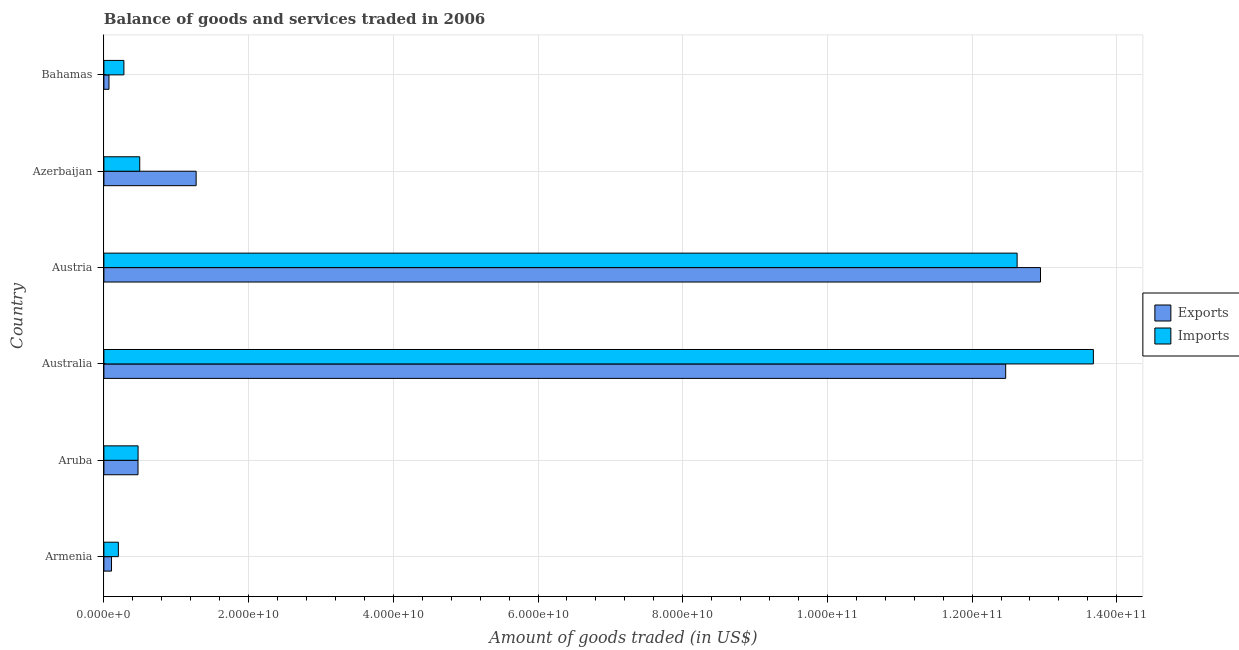How many different coloured bars are there?
Offer a very short reply. 2. How many groups of bars are there?
Your answer should be compact. 6. Are the number of bars per tick equal to the number of legend labels?
Your answer should be compact. Yes. How many bars are there on the 3rd tick from the bottom?
Your answer should be very brief. 2. What is the label of the 6th group of bars from the top?
Your answer should be compact. Armenia. What is the amount of goods imported in Australia?
Provide a succinct answer. 1.37e+11. Across all countries, what is the maximum amount of goods imported?
Offer a very short reply. 1.37e+11. Across all countries, what is the minimum amount of goods imported?
Keep it short and to the point. 2.00e+09. In which country was the amount of goods imported maximum?
Ensure brevity in your answer.  Australia. In which country was the amount of goods imported minimum?
Give a very brief answer. Armenia. What is the total amount of goods exported in the graph?
Give a very brief answer. 2.73e+11. What is the difference between the amount of goods exported in Australia and that in Bahamas?
Offer a terse response. 1.24e+11. What is the difference between the amount of goods exported in Australia and the amount of goods imported in Armenia?
Keep it short and to the point. 1.23e+11. What is the average amount of goods exported per country?
Give a very brief answer. 4.56e+1. What is the difference between the amount of goods exported and amount of goods imported in Australia?
Offer a very short reply. -1.21e+1. What is the ratio of the amount of goods exported in Australia to that in Austria?
Make the answer very short. 0.96. Is the amount of goods exported in Aruba less than that in Austria?
Ensure brevity in your answer.  Yes. Is the difference between the amount of goods exported in Australia and Austria greater than the difference between the amount of goods imported in Australia and Austria?
Provide a short and direct response. No. What is the difference between the highest and the second highest amount of goods exported?
Keep it short and to the point. 4.81e+09. What is the difference between the highest and the lowest amount of goods imported?
Make the answer very short. 1.35e+11. In how many countries, is the amount of goods imported greater than the average amount of goods imported taken over all countries?
Offer a terse response. 2. Is the sum of the amount of goods exported in Aruba and Bahamas greater than the maximum amount of goods imported across all countries?
Provide a succinct answer. No. What does the 2nd bar from the top in Australia represents?
Offer a terse response. Exports. What does the 2nd bar from the bottom in Austria represents?
Give a very brief answer. Imports. Are all the bars in the graph horizontal?
Ensure brevity in your answer.  Yes. How many countries are there in the graph?
Your answer should be very brief. 6. Are the values on the major ticks of X-axis written in scientific E-notation?
Your answer should be very brief. Yes. Does the graph contain any zero values?
Provide a succinct answer. No. How are the legend labels stacked?
Make the answer very short. Vertical. What is the title of the graph?
Make the answer very short. Balance of goods and services traded in 2006. What is the label or title of the X-axis?
Ensure brevity in your answer.  Amount of goods traded (in US$). What is the Amount of goods traded (in US$) in Exports in Armenia?
Offer a very short reply. 1.05e+09. What is the Amount of goods traded (in US$) of Imports in Armenia?
Your response must be concise. 2.00e+09. What is the Amount of goods traded (in US$) in Exports in Aruba?
Provide a short and direct response. 4.72e+09. What is the Amount of goods traded (in US$) in Imports in Aruba?
Offer a very short reply. 4.72e+09. What is the Amount of goods traded (in US$) of Exports in Australia?
Keep it short and to the point. 1.25e+11. What is the Amount of goods traded (in US$) in Imports in Australia?
Your answer should be compact. 1.37e+11. What is the Amount of goods traded (in US$) in Exports in Austria?
Ensure brevity in your answer.  1.29e+11. What is the Amount of goods traded (in US$) in Imports in Austria?
Provide a succinct answer. 1.26e+11. What is the Amount of goods traded (in US$) in Exports in Azerbaijan?
Keep it short and to the point. 1.27e+1. What is the Amount of goods traded (in US$) of Imports in Azerbaijan?
Offer a terse response. 4.95e+09. What is the Amount of goods traded (in US$) in Exports in Bahamas?
Keep it short and to the point. 7.04e+08. What is the Amount of goods traded (in US$) of Imports in Bahamas?
Provide a short and direct response. 2.77e+09. Across all countries, what is the maximum Amount of goods traded (in US$) in Exports?
Provide a succinct answer. 1.29e+11. Across all countries, what is the maximum Amount of goods traded (in US$) of Imports?
Provide a succinct answer. 1.37e+11. Across all countries, what is the minimum Amount of goods traded (in US$) of Exports?
Your answer should be compact. 7.04e+08. Across all countries, what is the minimum Amount of goods traded (in US$) in Imports?
Give a very brief answer. 2.00e+09. What is the total Amount of goods traded (in US$) of Exports in the graph?
Your response must be concise. 2.73e+11. What is the total Amount of goods traded (in US$) of Imports in the graph?
Ensure brevity in your answer.  2.77e+11. What is the difference between the Amount of goods traded (in US$) of Exports in Armenia and that in Aruba?
Make the answer very short. -3.66e+09. What is the difference between the Amount of goods traded (in US$) of Imports in Armenia and that in Aruba?
Offer a terse response. -2.72e+09. What is the difference between the Amount of goods traded (in US$) in Exports in Armenia and that in Australia?
Keep it short and to the point. -1.24e+11. What is the difference between the Amount of goods traded (in US$) in Imports in Armenia and that in Australia?
Make the answer very short. -1.35e+11. What is the difference between the Amount of goods traded (in US$) in Exports in Armenia and that in Austria?
Provide a succinct answer. -1.28e+11. What is the difference between the Amount of goods traded (in US$) in Imports in Armenia and that in Austria?
Your response must be concise. -1.24e+11. What is the difference between the Amount of goods traded (in US$) of Exports in Armenia and that in Azerbaijan?
Your answer should be very brief. -1.17e+1. What is the difference between the Amount of goods traded (in US$) in Imports in Armenia and that in Azerbaijan?
Offer a very short reply. -2.95e+09. What is the difference between the Amount of goods traded (in US$) in Exports in Armenia and that in Bahamas?
Ensure brevity in your answer.  3.49e+08. What is the difference between the Amount of goods traded (in US$) in Imports in Armenia and that in Bahamas?
Offer a very short reply. -7.67e+08. What is the difference between the Amount of goods traded (in US$) in Exports in Aruba and that in Australia?
Keep it short and to the point. -1.20e+11. What is the difference between the Amount of goods traded (in US$) of Imports in Aruba and that in Australia?
Your response must be concise. -1.32e+11. What is the difference between the Amount of goods traded (in US$) in Exports in Aruba and that in Austria?
Offer a terse response. -1.25e+11. What is the difference between the Amount of goods traded (in US$) of Imports in Aruba and that in Austria?
Make the answer very short. -1.21e+11. What is the difference between the Amount of goods traded (in US$) in Exports in Aruba and that in Azerbaijan?
Keep it short and to the point. -8.03e+09. What is the difference between the Amount of goods traded (in US$) of Imports in Aruba and that in Azerbaijan?
Your answer should be very brief. -2.30e+08. What is the difference between the Amount of goods traded (in US$) of Exports in Aruba and that in Bahamas?
Provide a succinct answer. 4.01e+09. What is the difference between the Amount of goods traded (in US$) of Imports in Aruba and that in Bahamas?
Make the answer very short. 1.96e+09. What is the difference between the Amount of goods traded (in US$) in Exports in Australia and that in Austria?
Offer a terse response. -4.81e+09. What is the difference between the Amount of goods traded (in US$) in Imports in Australia and that in Austria?
Provide a succinct answer. 1.05e+1. What is the difference between the Amount of goods traded (in US$) in Exports in Australia and that in Azerbaijan?
Make the answer very short. 1.12e+11. What is the difference between the Amount of goods traded (in US$) in Imports in Australia and that in Azerbaijan?
Give a very brief answer. 1.32e+11. What is the difference between the Amount of goods traded (in US$) of Exports in Australia and that in Bahamas?
Make the answer very short. 1.24e+11. What is the difference between the Amount of goods traded (in US$) of Imports in Australia and that in Bahamas?
Give a very brief answer. 1.34e+11. What is the difference between the Amount of goods traded (in US$) of Exports in Austria and that in Azerbaijan?
Your answer should be very brief. 1.17e+11. What is the difference between the Amount of goods traded (in US$) of Imports in Austria and that in Azerbaijan?
Keep it short and to the point. 1.21e+11. What is the difference between the Amount of goods traded (in US$) of Exports in Austria and that in Bahamas?
Offer a very short reply. 1.29e+11. What is the difference between the Amount of goods traded (in US$) in Imports in Austria and that in Bahamas?
Your answer should be compact. 1.23e+11. What is the difference between the Amount of goods traded (in US$) in Exports in Azerbaijan and that in Bahamas?
Make the answer very short. 1.20e+1. What is the difference between the Amount of goods traded (in US$) of Imports in Azerbaijan and that in Bahamas?
Your answer should be very brief. 2.19e+09. What is the difference between the Amount of goods traded (in US$) of Exports in Armenia and the Amount of goods traded (in US$) of Imports in Aruba?
Your response must be concise. -3.67e+09. What is the difference between the Amount of goods traded (in US$) of Exports in Armenia and the Amount of goods traded (in US$) of Imports in Australia?
Offer a very short reply. -1.36e+11. What is the difference between the Amount of goods traded (in US$) of Exports in Armenia and the Amount of goods traded (in US$) of Imports in Austria?
Your answer should be very brief. -1.25e+11. What is the difference between the Amount of goods traded (in US$) in Exports in Armenia and the Amount of goods traded (in US$) in Imports in Azerbaijan?
Provide a succinct answer. -3.90e+09. What is the difference between the Amount of goods traded (in US$) in Exports in Armenia and the Amount of goods traded (in US$) in Imports in Bahamas?
Make the answer very short. -1.71e+09. What is the difference between the Amount of goods traded (in US$) in Exports in Aruba and the Amount of goods traded (in US$) in Imports in Australia?
Your answer should be compact. -1.32e+11. What is the difference between the Amount of goods traded (in US$) in Exports in Aruba and the Amount of goods traded (in US$) in Imports in Austria?
Offer a terse response. -1.22e+11. What is the difference between the Amount of goods traded (in US$) in Exports in Aruba and the Amount of goods traded (in US$) in Imports in Azerbaijan?
Provide a short and direct response. -2.37e+08. What is the difference between the Amount of goods traded (in US$) of Exports in Aruba and the Amount of goods traded (in US$) of Imports in Bahamas?
Offer a terse response. 1.95e+09. What is the difference between the Amount of goods traded (in US$) of Exports in Australia and the Amount of goods traded (in US$) of Imports in Austria?
Your answer should be compact. -1.58e+09. What is the difference between the Amount of goods traded (in US$) of Exports in Australia and the Amount of goods traded (in US$) of Imports in Azerbaijan?
Ensure brevity in your answer.  1.20e+11. What is the difference between the Amount of goods traded (in US$) in Exports in Australia and the Amount of goods traded (in US$) in Imports in Bahamas?
Provide a succinct answer. 1.22e+11. What is the difference between the Amount of goods traded (in US$) in Exports in Austria and the Amount of goods traded (in US$) in Imports in Azerbaijan?
Your answer should be compact. 1.24e+11. What is the difference between the Amount of goods traded (in US$) of Exports in Austria and the Amount of goods traded (in US$) of Imports in Bahamas?
Your answer should be very brief. 1.27e+11. What is the difference between the Amount of goods traded (in US$) of Exports in Azerbaijan and the Amount of goods traded (in US$) of Imports in Bahamas?
Make the answer very short. 9.98e+09. What is the average Amount of goods traded (in US$) of Exports per country?
Provide a succinct answer. 4.56e+1. What is the average Amount of goods traded (in US$) of Imports per country?
Provide a succinct answer. 4.62e+1. What is the difference between the Amount of goods traded (in US$) of Exports and Amount of goods traded (in US$) of Imports in Armenia?
Provide a short and direct response. -9.47e+08. What is the difference between the Amount of goods traded (in US$) of Exports and Amount of goods traded (in US$) of Imports in Aruba?
Your response must be concise. -7.32e+06. What is the difference between the Amount of goods traded (in US$) of Exports and Amount of goods traded (in US$) of Imports in Australia?
Provide a succinct answer. -1.21e+1. What is the difference between the Amount of goods traded (in US$) of Exports and Amount of goods traded (in US$) of Imports in Austria?
Your answer should be compact. 3.23e+09. What is the difference between the Amount of goods traded (in US$) in Exports and Amount of goods traded (in US$) in Imports in Azerbaijan?
Your answer should be very brief. 7.80e+09. What is the difference between the Amount of goods traded (in US$) in Exports and Amount of goods traded (in US$) in Imports in Bahamas?
Provide a succinct answer. -2.06e+09. What is the ratio of the Amount of goods traded (in US$) of Exports in Armenia to that in Aruba?
Provide a short and direct response. 0.22. What is the ratio of the Amount of goods traded (in US$) in Imports in Armenia to that in Aruba?
Give a very brief answer. 0.42. What is the ratio of the Amount of goods traded (in US$) in Exports in Armenia to that in Australia?
Ensure brevity in your answer.  0.01. What is the ratio of the Amount of goods traded (in US$) in Imports in Armenia to that in Australia?
Provide a succinct answer. 0.01. What is the ratio of the Amount of goods traded (in US$) in Exports in Armenia to that in Austria?
Keep it short and to the point. 0.01. What is the ratio of the Amount of goods traded (in US$) of Imports in Armenia to that in Austria?
Provide a succinct answer. 0.02. What is the ratio of the Amount of goods traded (in US$) of Exports in Armenia to that in Azerbaijan?
Your answer should be very brief. 0.08. What is the ratio of the Amount of goods traded (in US$) of Imports in Armenia to that in Azerbaijan?
Give a very brief answer. 0.4. What is the ratio of the Amount of goods traded (in US$) of Exports in Armenia to that in Bahamas?
Offer a very short reply. 1.5. What is the ratio of the Amount of goods traded (in US$) of Imports in Armenia to that in Bahamas?
Ensure brevity in your answer.  0.72. What is the ratio of the Amount of goods traded (in US$) in Exports in Aruba to that in Australia?
Provide a short and direct response. 0.04. What is the ratio of the Amount of goods traded (in US$) in Imports in Aruba to that in Australia?
Keep it short and to the point. 0.03. What is the ratio of the Amount of goods traded (in US$) of Exports in Aruba to that in Austria?
Provide a succinct answer. 0.04. What is the ratio of the Amount of goods traded (in US$) in Imports in Aruba to that in Austria?
Provide a succinct answer. 0.04. What is the ratio of the Amount of goods traded (in US$) of Exports in Aruba to that in Azerbaijan?
Make the answer very short. 0.37. What is the ratio of the Amount of goods traded (in US$) in Imports in Aruba to that in Azerbaijan?
Offer a very short reply. 0.95. What is the ratio of the Amount of goods traded (in US$) in Exports in Aruba to that in Bahamas?
Make the answer very short. 6.7. What is the ratio of the Amount of goods traded (in US$) of Imports in Aruba to that in Bahamas?
Ensure brevity in your answer.  1.71. What is the ratio of the Amount of goods traded (in US$) of Exports in Australia to that in Austria?
Provide a short and direct response. 0.96. What is the ratio of the Amount of goods traded (in US$) of Imports in Australia to that in Austria?
Provide a succinct answer. 1.08. What is the ratio of the Amount of goods traded (in US$) in Exports in Australia to that in Azerbaijan?
Your response must be concise. 9.78. What is the ratio of the Amount of goods traded (in US$) of Imports in Australia to that in Azerbaijan?
Make the answer very short. 27.61. What is the ratio of the Amount of goods traded (in US$) of Exports in Australia to that in Bahamas?
Your answer should be very brief. 177.16. What is the ratio of the Amount of goods traded (in US$) of Imports in Australia to that in Bahamas?
Your response must be concise. 49.43. What is the ratio of the Amount of goods traded (in US$) in Exports in Austria to that in Azerbaijan?
Provide a succinct answer. 10.15. What is the ratio of the Amount of goods traded (in US$) of Imports in Austria to that in Azerbaijan?
Offer a very short reply. 25.48. What is the ratio of the Amount of goods traded (in US$) in Exports in Austria to that in Bahamas?
Your response must be concise. 184. What is the ratio of the Amount of goods traded (in US$) in Imports in Austria to that in Bahamas?
Your answer should be very brief. 45.62. What is the ratio of the Amount of goods traded (in US$) of Exports in Azerbaijan to that in Bahamas?
Ensure brevity in your answer.  18.12. What is the ratio of the Amount of goods traded (in US$) of Imports in Azerbaijan to that in Bahamas?
Ensure brevity in your answer.  1.79. What is the difference between the highest and the second highest Amount of goods traded (in US$) in Exports?
Make the answer very short. 4.81e+09. What is the difference between the highest and the second highest Amount of goods traded (in US$) of Imports?
Keep it short and to the point. 1.05e+1. What is the difference between the highest and the lowest Amount of goods traded (in US$) in Exports?
Your answer should be very brief. 1.29e+11. What is the difference between the highest and the lowest Amount of goods traded (in US$) in Imports?
Your answer should be very brief. 1.35e+11. 